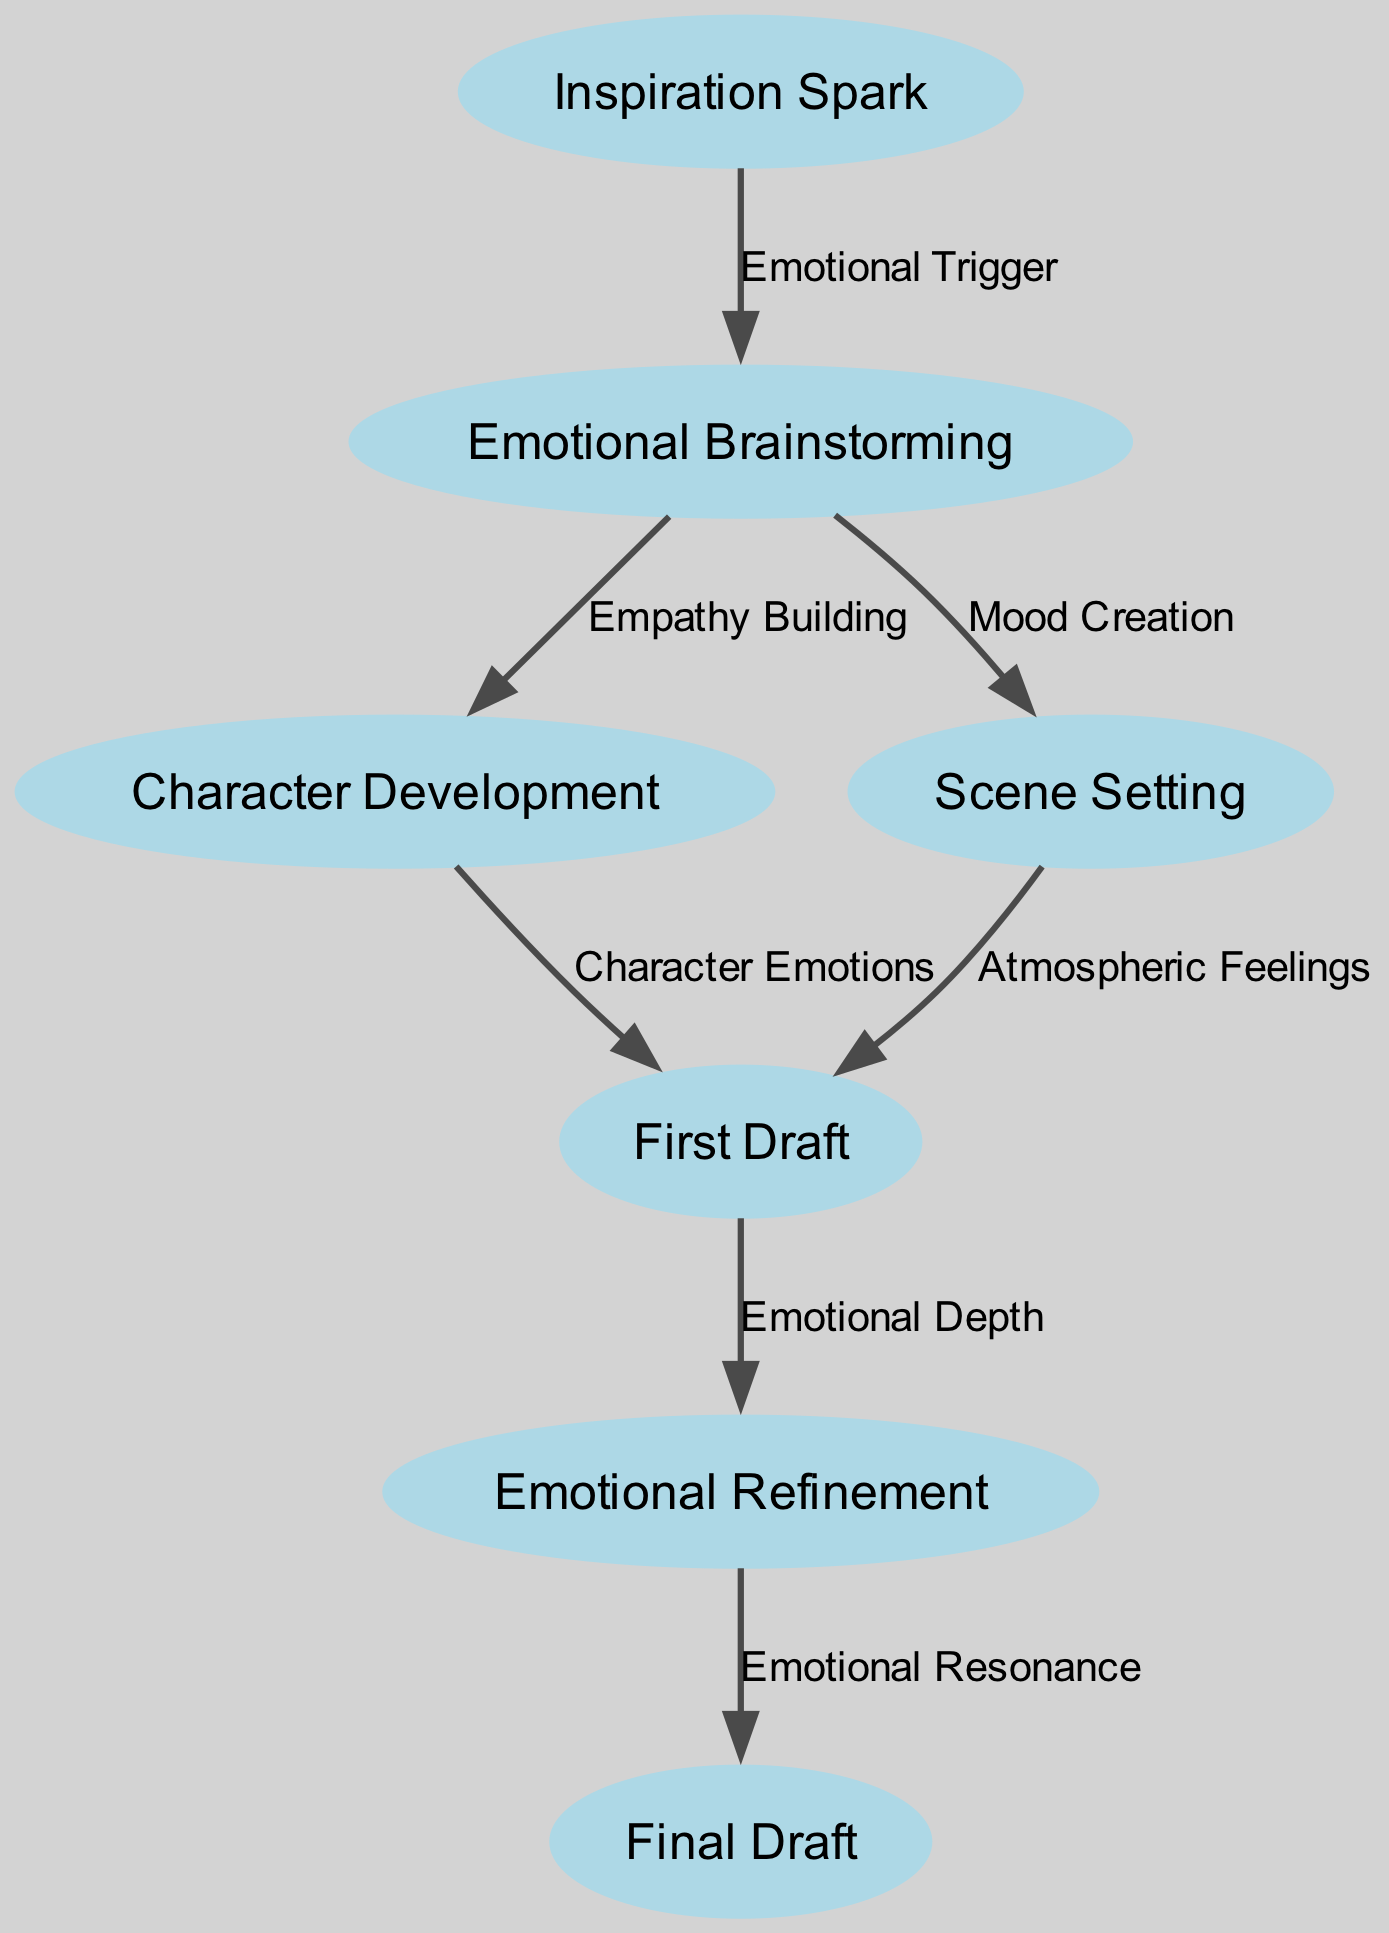What is the first node in the diagram? The first node in the diagram is labeled "Inspiration Spark". Since the diagram flows from node to node, the starting point is identified as the first one listed.
Answer: Inspiration Spark How many nodes are in the diagram? Counting each unique node listed in the data reveals a total of seven nodes: Inspiration Spark, Emotional Brainstorming, Character Development, Scene Setting, First Draft, Emotional Refinement, and Final Draft.
Answer: 7 What label connects "Emotional Brainstorming" to "Character Development"? The label that connects "Emotional Brainstorming" to "Character Development" is "Empathy Building". This relationship is represented as an edge in the diagram.
Answer: Empathy Building What is the last node in the flow? The last node in the flow, which is reached after traversing all previous nodes, is "Final Draft". It represents the culmination of the creative writing process shown in the diagram.
Answer: Final Draft Which two nodes connect to "First Draft"? "Character Development" and "Scene Setting" both connect to "First Draft". Each shows how character and atmosphere contribute directly to the creation of the first draft.
Answer: Character Development, Scene Setting How many edges are there in total? By counting each directed connection (edge) between nodes, we find there are a total of six edges making up the relationships between the nodes.
Answer: 6 What does the edge from "Emotional Refinement" to "Final Draft" represent? The edge from "Emotional Refinement" to "Final Draft" represents "Emotional Resonance". It signifies the final emotional adjustments made before completing the draft.
Answer: Emotional Resonance What is the relationship between "Inspiration Spark" and "Emotional Brainstorming"? The relationship between "Inspiration Spark" and "Emotional Brainstorming" is labeled as "Emotional Trigger". This indicates that the initial spark of inspiration leads to brainstorming emotions related to the writing.
Answer: Emotional Trigger What does "Atmospheric Feelings" connect to? "Atmospheric Feelings" connects to "First Draft". This connection underscores how the mood set in the scene influences the early version of the writing.
Answer: First Draft 